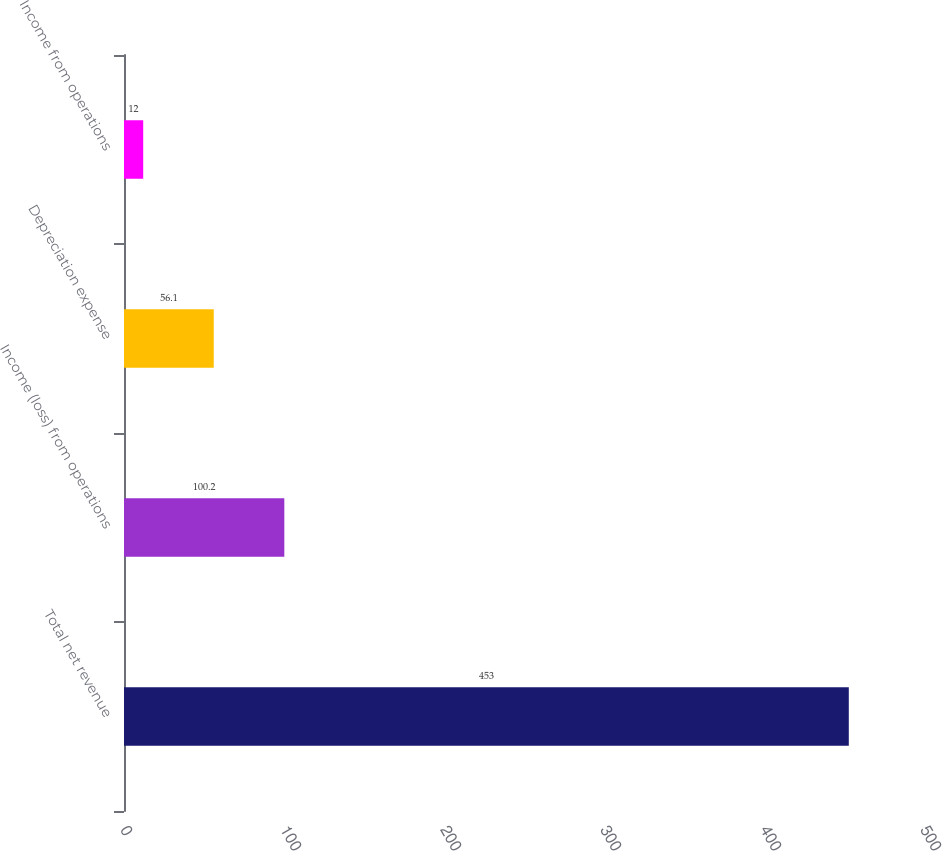Convert chart. <chart><loc_0><loc_0><loc_500><loc_500><bar_chart><fcel>Total net revenue<fcel>Income (loss) from operations<fcel>Depreciation expense<fcel>Income from operations<nl><fcel>453<fcel>100.2<fcel>56.1<fcel>12<nl></chart> 